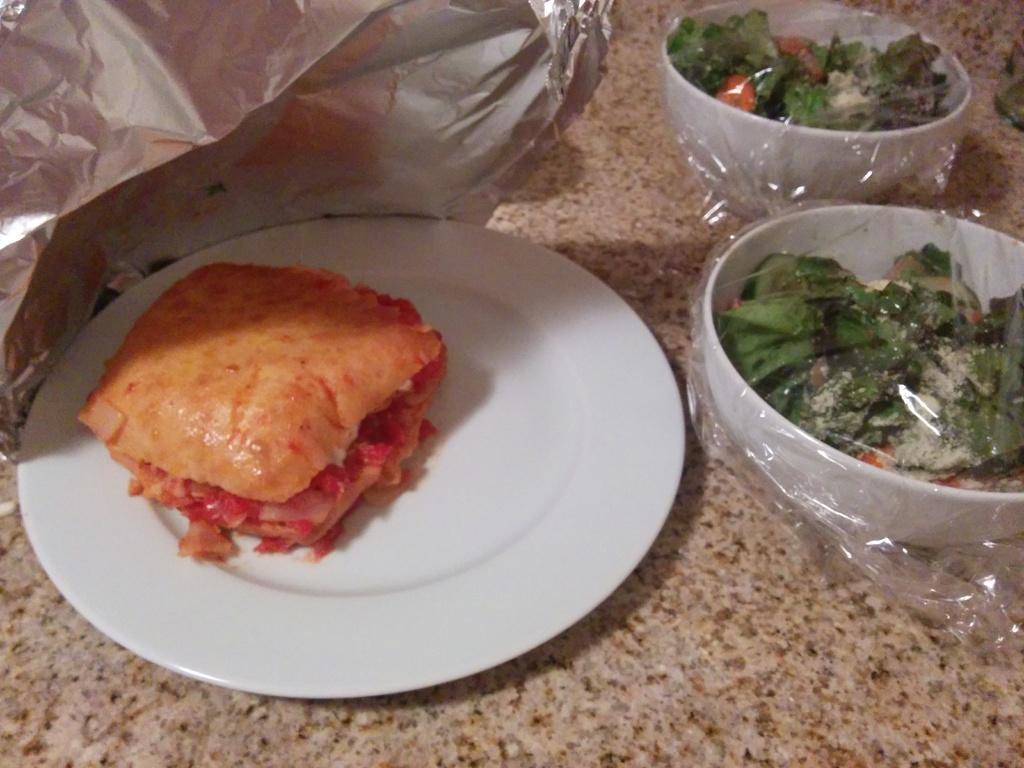Could you give a brief overview of what you see in this image? In this image we can see a food item kept on the white plate and we can see two bowls in which we can see food items and it is covered with a cover and here we can see the paper which are placed on the marble surface. 